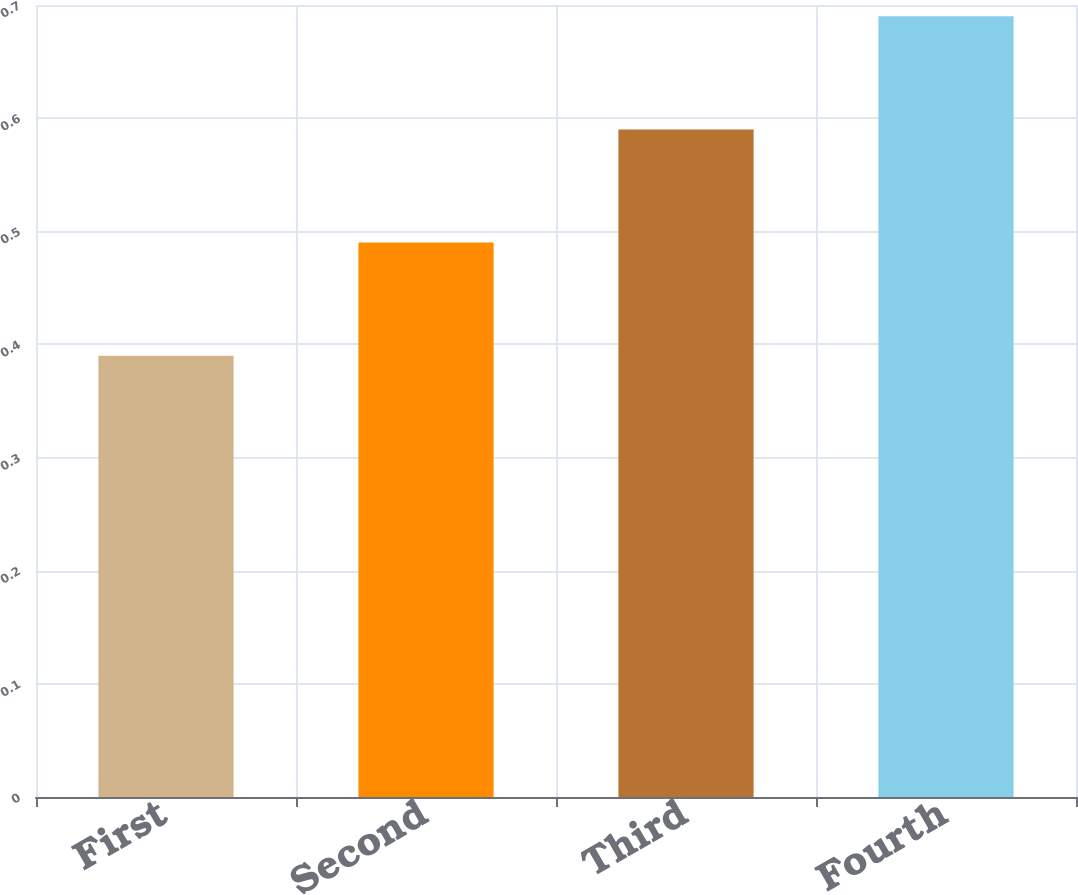Convert chart. <chart><loc_0><loc_0><loc_500><loc_500><bar_chart><fcel>First<fcel>Second<fcel>Third<fcel>Fourth<nl><fcel>0.39<fcel>0.49<fcel>0.59<fcel>0.69<nl></chart> 